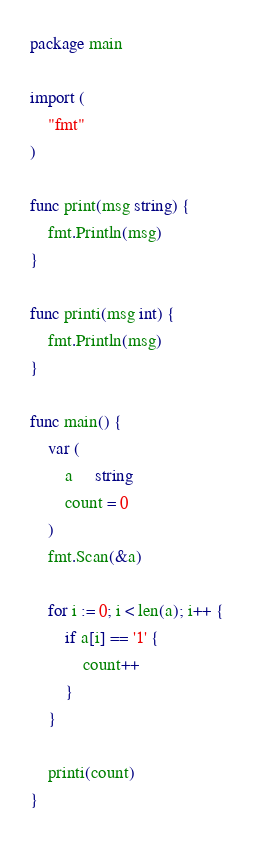<code> <loc_0><loc_0><loc_500><loc_500><_Go_>package main

import (
	"fmt"
)

func print(msg string) {
	fmt.Println(msg)
}

func printi(msg int) {
	fmt.Println(msg)
}

func main() {
	var (
		a     string
		count = 0
	)
	fmt.Scan(&a)

	for i := 0; i < len(a); i++ {
		if a[i] == '1' {
			count++
		}
	}

	printi(count)
}
</code> 